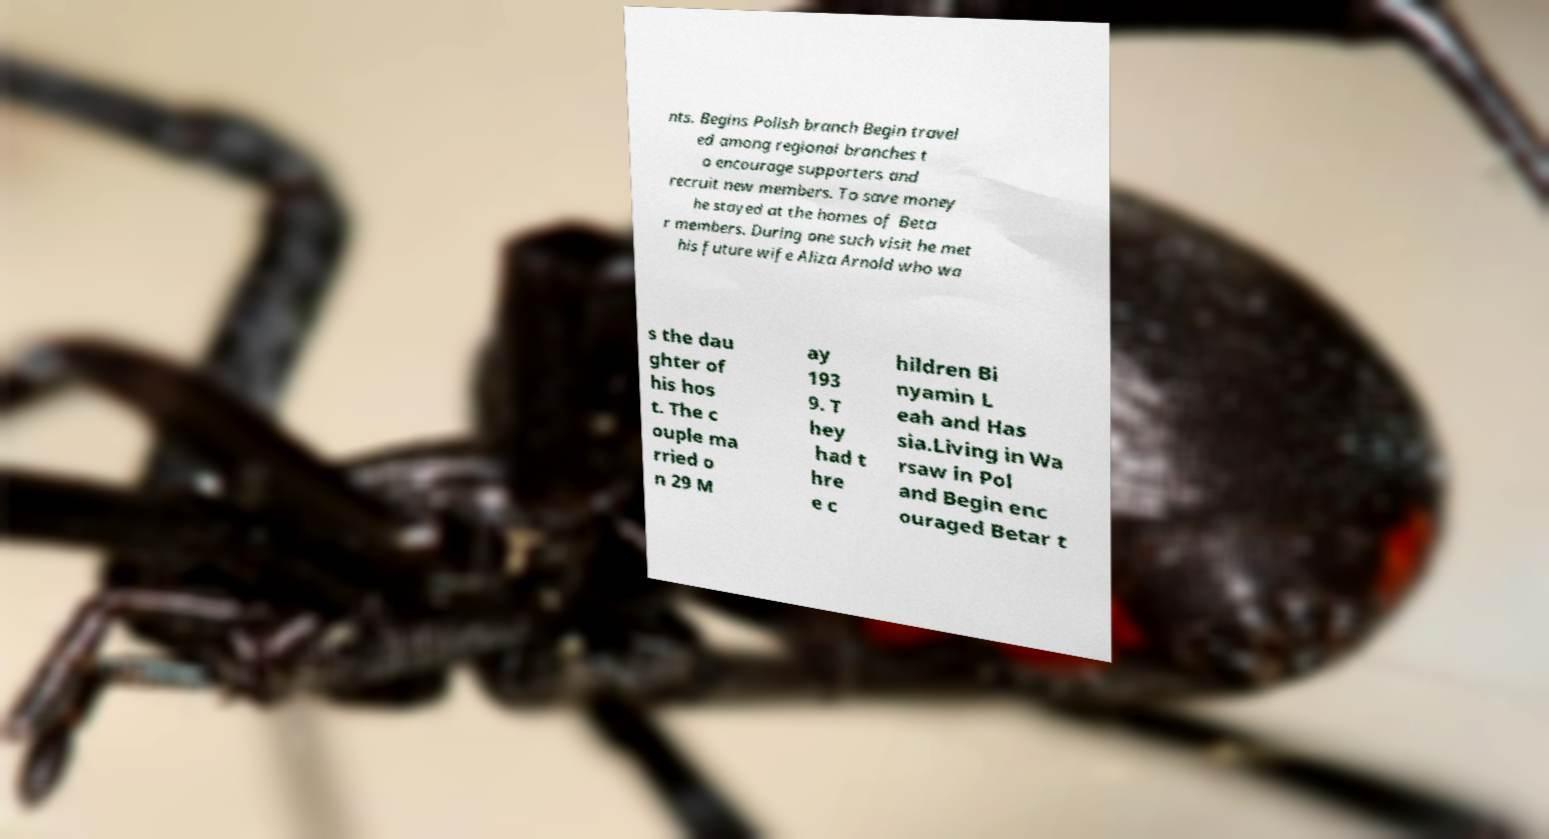What messages or text are displayed in this image? I need them in a readable, typed format. nts. Begins Polish branch Begin travel ed among regional branches t o encourage supporters and recruit new members. To save money he stayed at the homes of Beta r members. During one such visit he met his future wife Aliza Arnold who wa s the dau ghter of his hos t. The c ouple ma rried o n 29 M ay 193 9. T hey had t hre e c hildren Bi nyamin L eah and Has sia.Living in Wa rsaw in Pol and Begin enc ouraged Betar t 